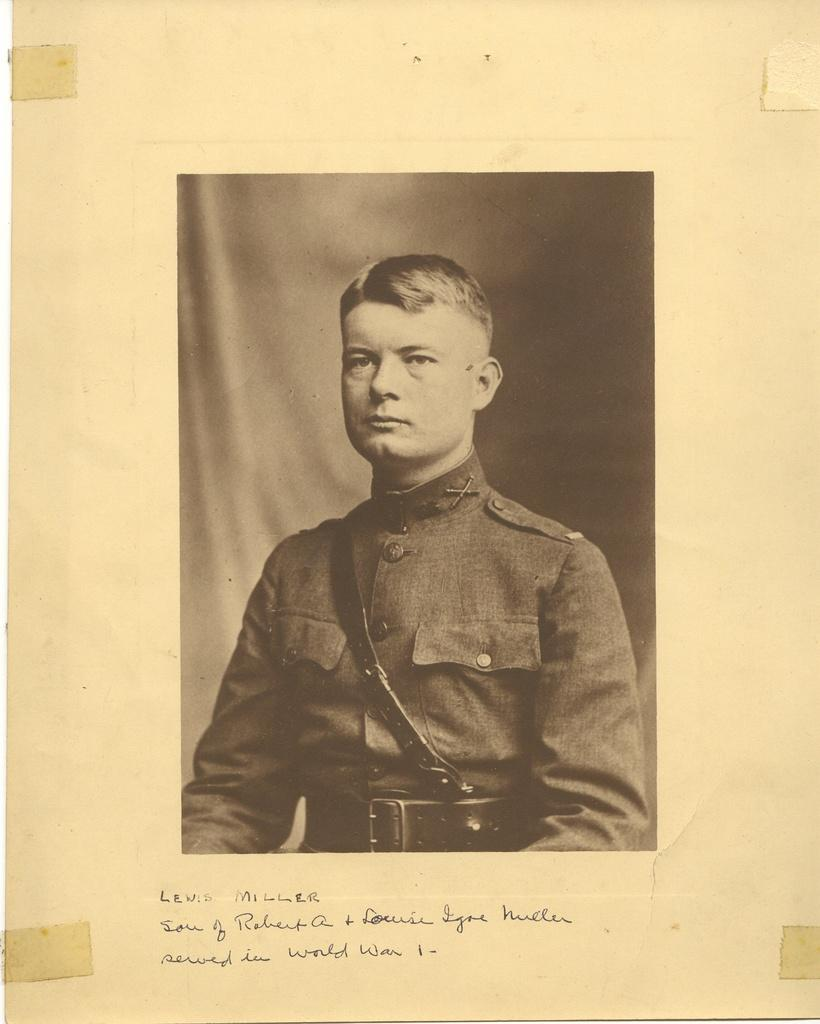What is the main subject of the image? The main subject of the image is a photo of a man. Where is the photo located in the image? The photo is on a page. What else can be seen on the page besides the photo? There is text at the bottom of the photo. Can you tell me how many frogs are jumping in the photo? There are no frogs present in the image; it features a photo of a man. What type of motion is depicted in the photo? The photo is still, and there is no motion depicted in the image. 